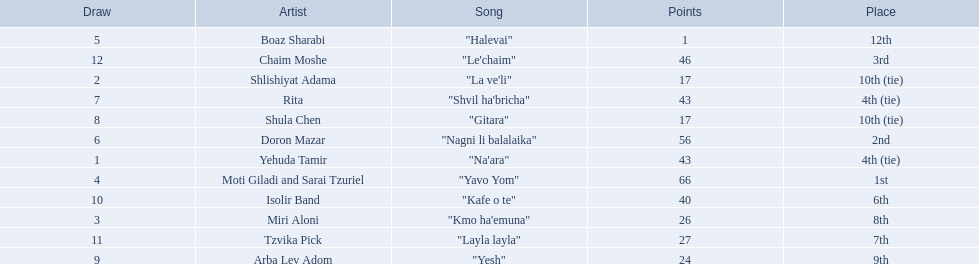How many artists are there? Yehuda Tamir, Shlishiyat Adama, Miri Aloni, Moti Giladi and Sarai Tzuriel, Boaz Sharabi, Doron Mazar, Rita, Shula Chen, Arba Lev Adom, Isolir Band, Tzvika Pick, Chaim Moshe. What is the least amount of points awarded? 1. Who was the artist awarded those points? Boaz Sharabi. 